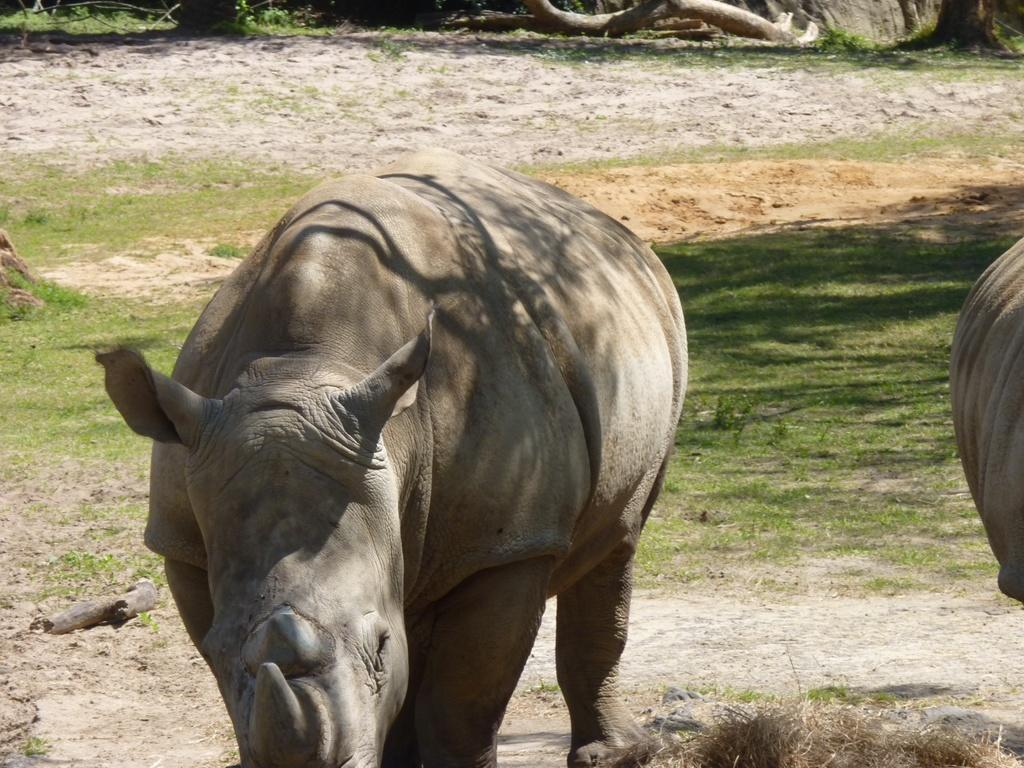What type of living organisms are present in the image? There are animals in the image. Can you describe the position of the animals in the image? The animals are on the ground in the image. What type of furniture is visible in the image? There is no furniture visible in the image; it features animals on the ground. Who created the animals in the image? The image does not provide information about the creator of the animals. 